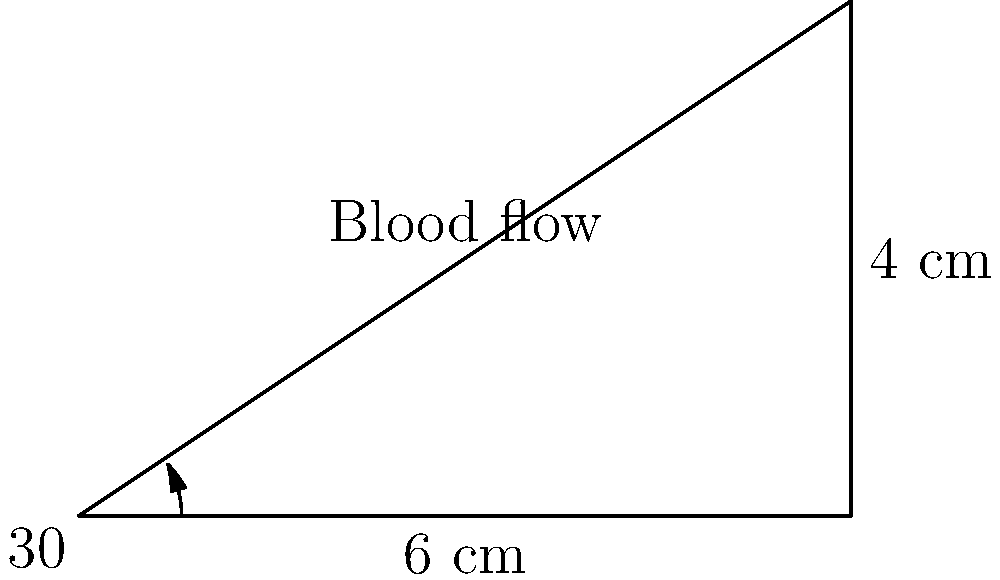In a study of blood flow through an artery, you observe that the artery forms a right-angled triangle with dimensions as shown in the diagram. If the blood travels 6 cm along the base of the triangle in 0.15 seconds, what is the velocity of blood flow through the artery (in cm/s)? To solve this problem, we need to follow these steps:

1) First, we need to identify the angle of the artery relative to the horizontal. From the diagram, we can see this is 30°.

2) The blood travels 6 cm along the base in 0.15 seconds. However, we need to find the distance along the hypotenuse (the artery itself).

3) We can use the cosine ratio to find the length of the hypotenuse:

   $\cos 30° = \frac{\text{adjacent}}{\text{hypotenuse}} = \frac{6}{\text{hypotenuse}}$

4) Rearranging this equation:

   $\text{hypotenuse} = \frac{6}{\cos 30°}$

5) We know that $\cos 30° = \frac{\sqrt{3}}{2}$, so:

   $\text{hypotenuse} = \frac{6}{\frac{\sqrt{3}}{2}} = \frac{12}{\sqrt{3}} = 4\sqrt{3}$ cm

6) Now we have the actual distance the blood travels. To find velocity, we use the formula:

   $\text{velocity} = \frac{\text{distance}}{\text{time}}$

7) Plugging in our values:

   $\text{velocity} = \frac{4\sqrt{3} \text{ cm}}{0.15 \text{ s}} = \frac{4\sqrt{3}}{0.15} \text{ cm/s} = \frac{80\sqrt{3}}{3} \text{ cm/s}$

8) This simplifies to approximately 46.19 cm/s.
Answer: $\frac{80\sqrt{3}}{3}$ cm/s or approximately 46.19 cm/s 